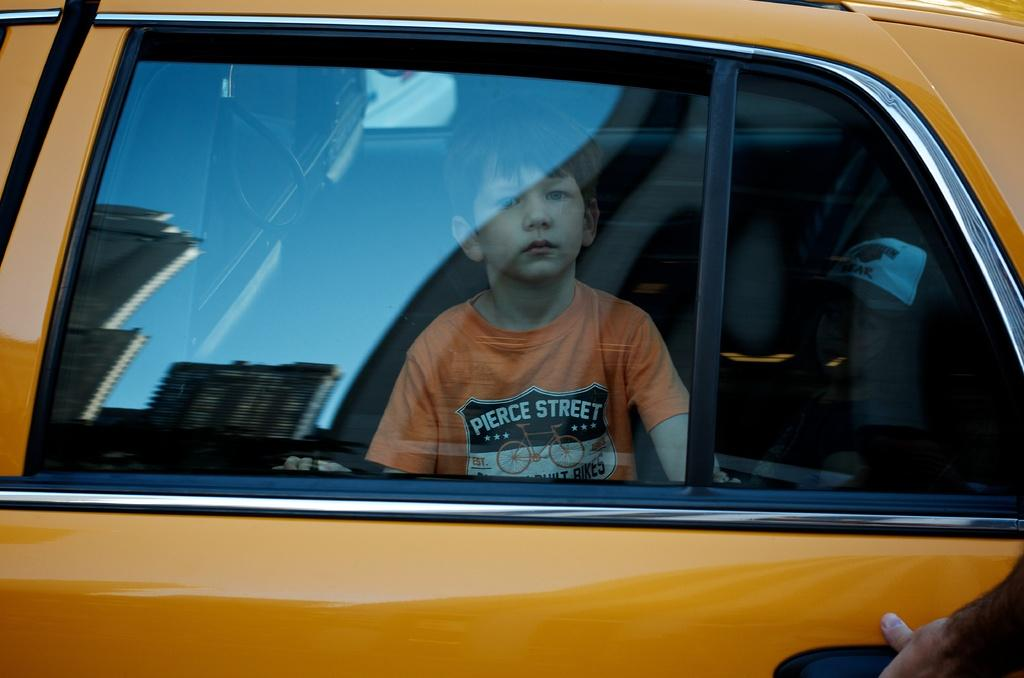<image>
Offer a succinct explanation of the picture presented. a boy in a taxi with Pierce Street on his shirt 